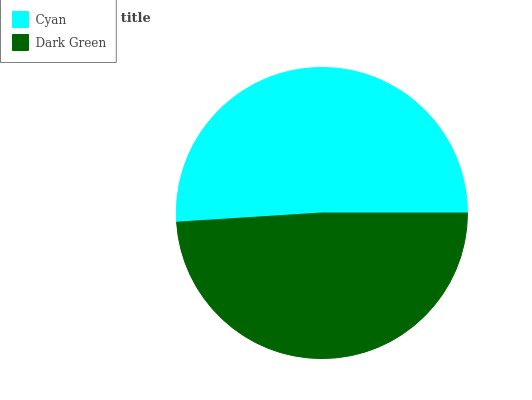Is Dark Green the minimum?
Answer yes or no. Yes. Is Cyan the maximum?
Answer yes or no. Yes. Is Dark Green the maximum?
Answer yes or no. No. Is Cyan greater than Dark Green?
Answer yes or no. Yes. Is Dark Green less than Cyan?
Answer yes or no. Yes. Is Dark Green greater than Cyan?
Answer yes or no. No. Is Cyan less than Dark Green?
Answer yes or no. No. Is Cyan the high median?
Answer yes or no. Yes. Is Dark Green the low median?
Answer yes or no. Yes. Is Dark Green the high median?
Answer yes or no. No. Is Cyan the low median?
Answer yes or no. No. 